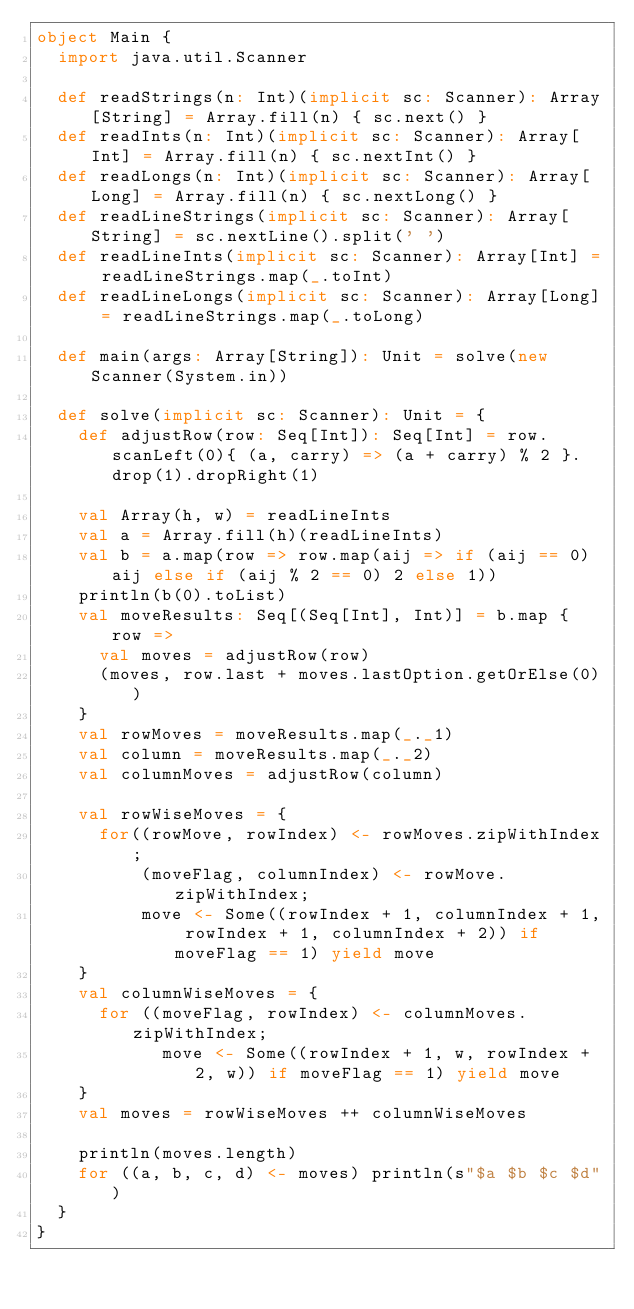Convert code to text. <code><loc_0><loc_0><loc_500><loc_500><_Scala_>object Main {
  import java.util.Scanner

  def readStrings(n: Int)(implicit sc: Scanner): Array[String] = Array.fill(n) { sc.next() }
  def readInts(n: Int)(implicit sc: Scanner): Array[Int] = Array.fill(n) { sc.nextInt() }
  def readLongs(n: Int)(implicit sc: Scanner): Array[Long] = Array.fill(n) { sc.nextLong() }
  def readLineStrings(implicit sc: Scanner): Array[String] = sc.nextLine().split(' ')
  def readLineInts(implicit sc: Scanner): Array[Int] = readLineStrings.map(_.toInt)
  def readLineLongs(implicit sc: Scanner): Array[Long] = readLineStrings.map(_.toLong)

  def main(args: Array[String]): Unit = solve(new Scanner(System.in))

  def solve(implicit sc: Scanner): Unit = {
    def adjustRow(row: Seq[Int]): Seq[Int] = row.scanLeft(0){ (a, carry) => (a + carry) % 2 }.drop(1).dropRight(1)

    val Array(h, w) = readLineInts
    val a = Array.fill(h)(readLineInts)
    val b = a.map(row => row.map(aij => if (aij == 0) aij else if (aij % 2 == 0) 2 else 1))
    println(b(0).toList)
    val moveResults: Seq[(Seq[Int], Int)] = b.map { row =>
      val moves = adjustRow(row)
      (moves, row.last + moves.lastOption.getOrElse(0))
    }
    val rowMoves = moveResults.map(_._1)
    val column = moveResults.map(_._2)
    val columnMoves = adjustRow(column)

    val rowWiseMoves = {
      for((rowMove, rowIndex) <- rowMoves.zipWithIndex;
          (moveFlag, columnIndex) <- rowMove.zipWithIndex;
          move <- Some((rowIndex + 1, columnIndex + 1, rowIndex + 1, columnIndex + 2)) if moveFlag == 1) yield move
    }
    val columnWiseMoves = {
      for ((moveFlag, rowIndex) <- columnMoves.zipWithIndex;
            move <- Some((rowIndex + 1, w, rowIndex + 2, w)) if moveFlag == 1) yield move
    }
    val moves = rowWiseMoves ++ columnWiseMoves

    println(moves.length)
    for ((a, b, c, d) <- moves) println(s"$a $b $c $d")
  }
}
</code> 